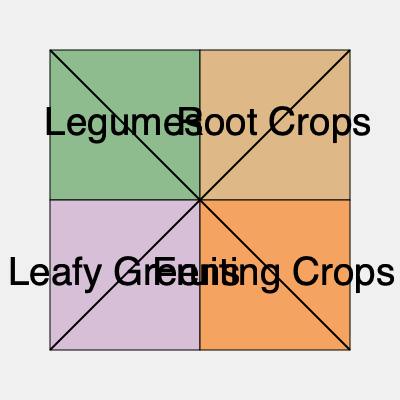In the given crop rotation diagram, which crop family should follow legumes in the next growing season to maximize soil nutrient balance and pest management? To answer this question, we need to understand the principles of crop rotation and how different plant families affect soil health:

1. Legumes (e.g., beans, peas) fix nitrogen in the soil, improving its fertility.
2. Root crops (e.g., carrots, potatoes) break up soil and use up nutrients.
3. Leafy greens (e.g., lettuce, spinach) are generally light feeders.
4. Fruiting crops (e.g., tomatoes, peppers) are heavy feeders and deplete soil nutrients.

The ideal crop rotation sequence is:

1. Legumes → Root Crops → Leafy Greens → Fruiting Crops

This sequence maximizes nutrient utilization and minimizes pest and disease issues because:

a) Root crops benefit from the nitrogen fixed by legumes.
b) Leafy greens, being light feeders, follow root crops which have broken up the soil.
c) Fruiting crops, as heavy feeders, come last to utilize remaining nutrients.
d) The rotation helps break pest and disease cycles specific to each plant family.

In the diagram, the arrows indicate the direction of rotation. Following the clockwise direction from legumes, we can see that root crops should be planted next.
Answer: Root Crops 